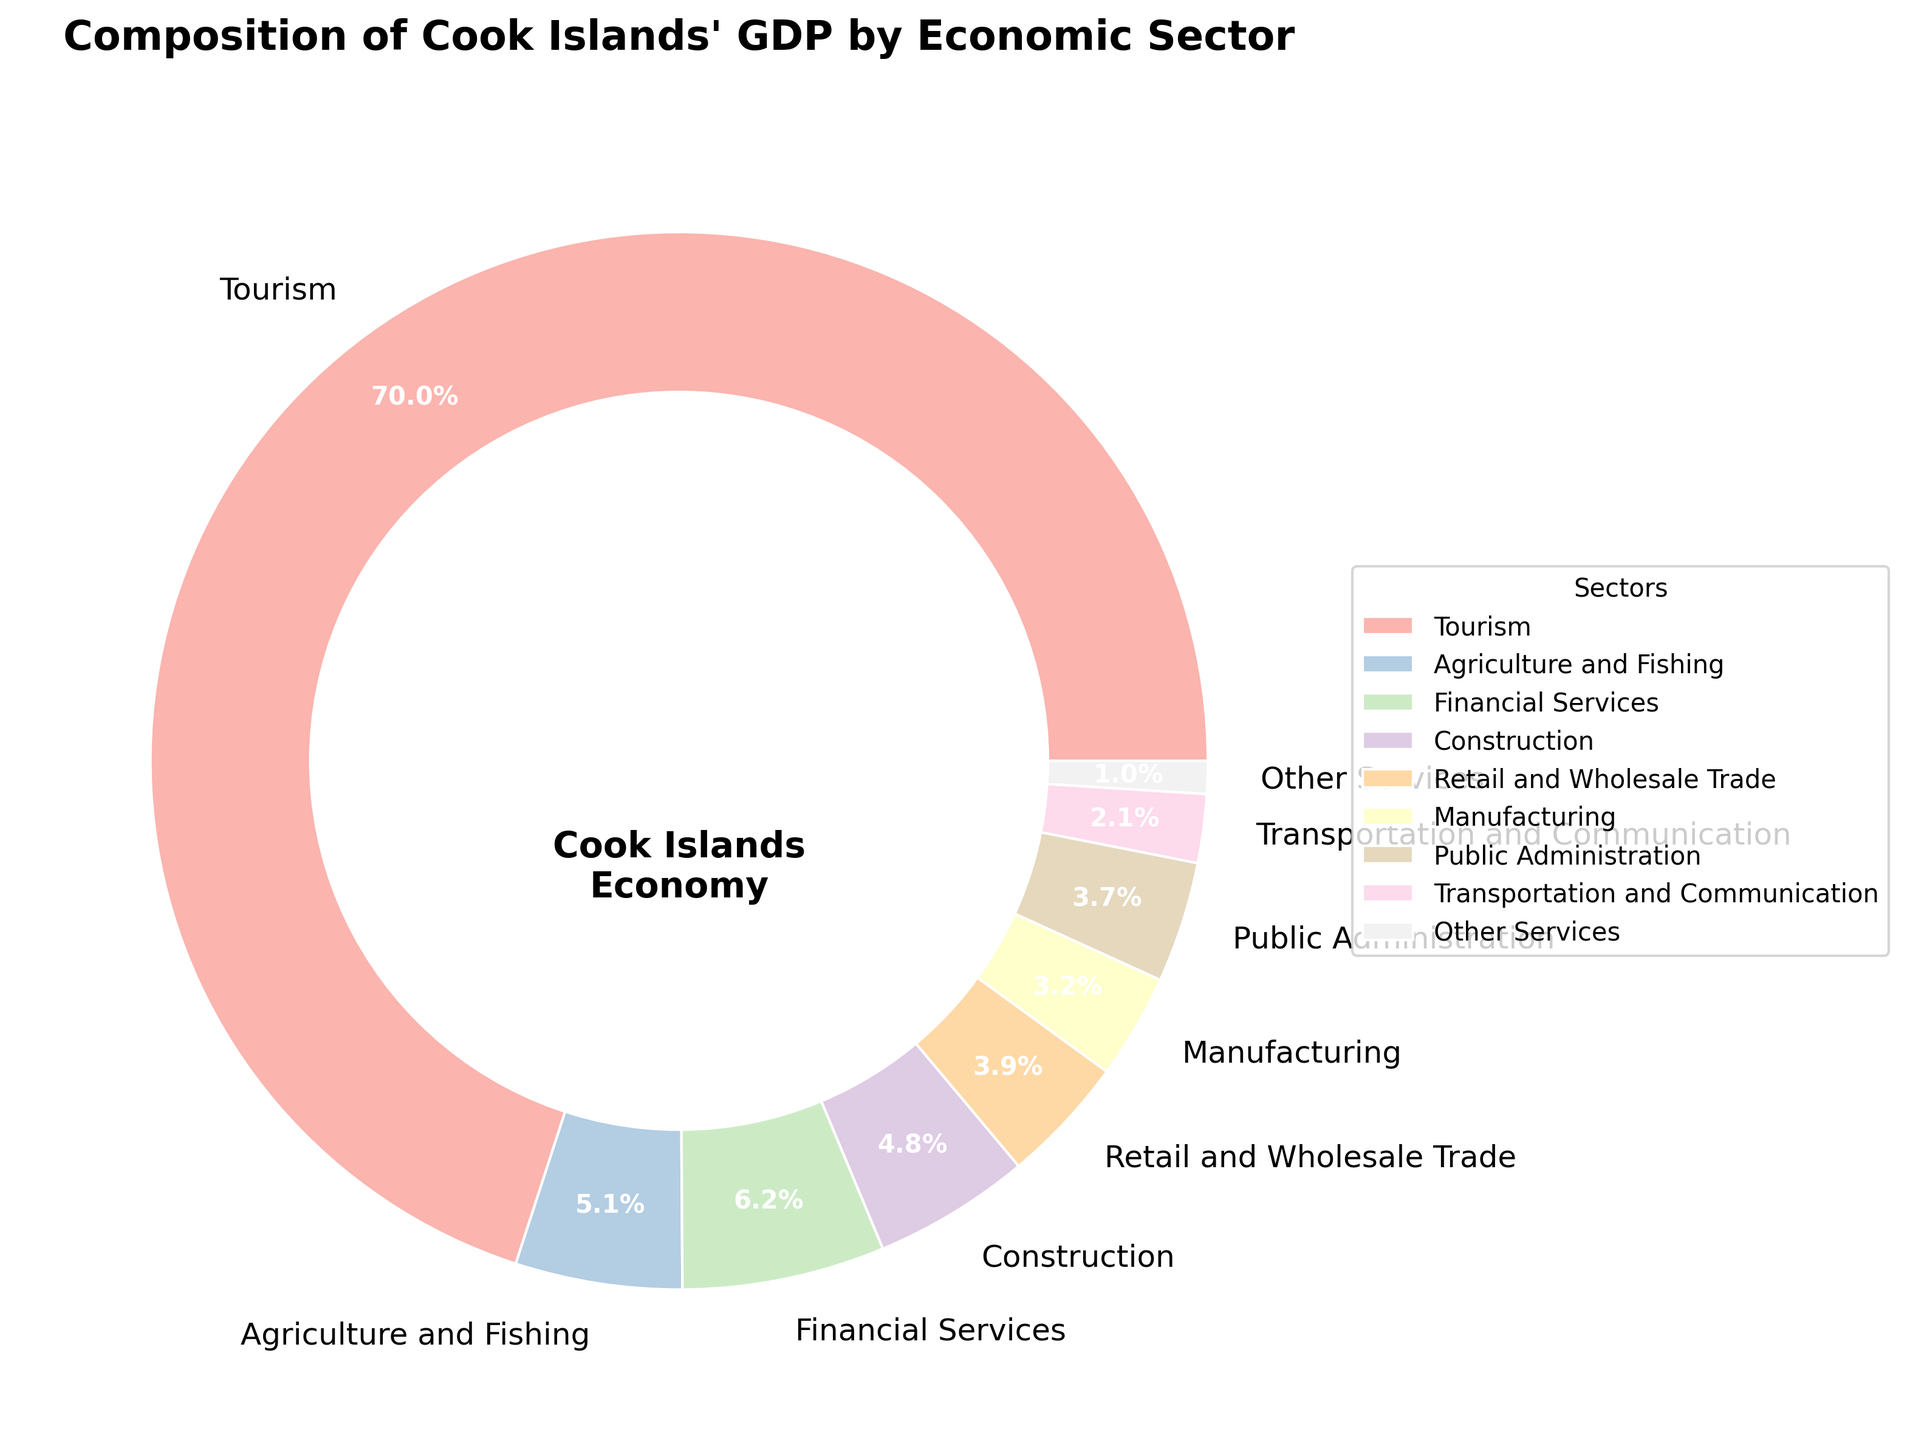Which sector contributes the most to Cook Islands' GDP? The pie chart shows that the largest portion of the GDP is from the sector labeled 'Tourism' with 70%.
Answer: Tourism What is the combined GDP percentage of Agriculture and Fishing, and Financial Services? According to the figure, Agriculture and Fishing contribute 5.1% and Financial Services contribute 6.2%. Adding these together: 5.1 + 6.2 = 11.3%.
Answer: 11.3% Which sector contributes the least to Cook Islands' GDP? The pie chart shows 'Other Services' has the smallest portion of the GDP with 1%.
Answer: Other Services Is the contribution of Transportation and Communication greater than that of Manufacturing? According to the chart, Transportation and Communication contribute 2.1%, and Manufacturing contributes 3.2%. Therefore, Transportation and Communication's contribution is less.
Answer: No How does the percentage of Retail and Wholesale Trade compare to that of Public Administration? The pie chart shows that Retail and Wholesale Trade contribute 3.9%, while Public Administration contributes 3.7%. Retail and Wholesale Trade has a slightly higher contribution.
Answer: Retail and Wholesale Trade is higher How much more does the Construction sector contribute to GDP than the Transportation and Communication sector? Construction contributes 4.8%, and Transportation and Communication contribute 2.1%. The difference is 4.8 - 2.1 = 2.7%.
Answer: 2.7% What proportion of Cook Islands' GDP is contributed by sectors other than Tourism? The total percentage of GDP is 100%. Tourism contributes 70%, so sectors other than Tourism contribute 100 - 70 = 30%.
Answer: 30% Does the pie chart use distinct colors for each sector? Visually inspecting the pie chart, each sector wedge appears in a different color, ensuring distinction between them.
Answer: Yes Identify the sectors contributing more than 5% to Cook Islands' GDP. Referring to the pie chart, the sectors that contribute more than 5% are Tourism (70%) and Financial Services (6.2%).
Answer: Tourism, Financial Services How does the total contribution of Agriculture and Fishing, and Manufacturing compare to the Construction sector? Agriculture and Fishing contributes 5.1%, and Manufacturing contributes 3.2%, totaling 5.1 + 3.2 = 8.3%. Construction alone contributes 4.8%, so the total of Agriculture and Fishing and Manufacturing is greater.
Answer: Agriculture and Fishing and Manufacturing together is greater 